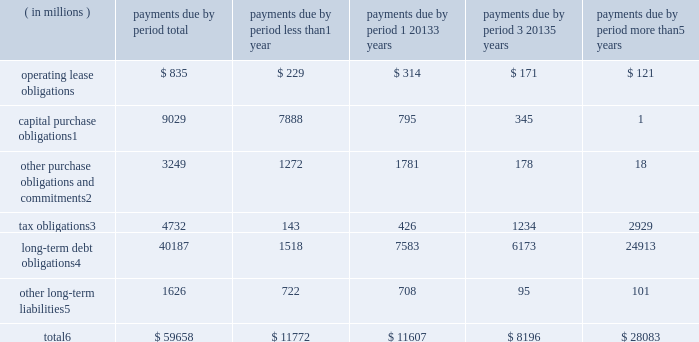Contractual obligations significant contractual obligations as of december 29 , 2018 were as follows: .
Capital purchase obligations1 9029 7888 795 345 1 other purchase obligations and commitments2 3249 1272 1781 178 18 tax obligations3 4732 143 426 1234 2929 long-term debt obligations4 40187 1518 7583 6173 24913 other long-term liabilities5 1626 722 708 95 101 total6 $ 59658 $ 11772 $ 11607 $ 8196 $ 28083 1 capital purchase obligations represent commitments for the construction or purchase of property , plant and equipment .
They were not recorded as liabilities on our consolidated balance sheets as of december 29 , 2018 , as we had not yet received the related goods nor taken title to the property .
2 other purchase obligations and commitments include payments due under various types of licenses and agreements to purchase goods or services , as well as payments due under non-contingent funding obligations .
3 tax obligations represent the future cash payments related to tax reform enacted in 2017 for the one-time transition tax on our previously untaxed foreign earnings .
For further information , see 201cnote 9 : income taxes 201d within the consolidated financial statements .
4 amounts represent principal payments for all debt obligations and interest payments for fixed-rate debt obligations .
Interest payments on floating-rate debt obligations , as well as the impact of fixed-rate to floating-rate debt swaps , are excluded .
Debt obligations are classified based on their stated maturity date , regardless of their classification on the consolidated balance sheets .
Any future settlement of convertible debt would impact our cash payments .
5 amounts represent future cash payments to satisfy other long-term liabilities recorded on our consolidated balance sheets , including the short-term portion of these long-term liabilities .
Derivative instruments are excluded from the preceding table , as they do not represent the amounts that may ultimately be paid .
6 total excludes contractual obligations already recorded on our consolidated balance sheets as current liabilities , except for the short-term portions of long-term debt obligations and other long-term liabilities .
The expected timing of payments of the obligations in the preceding table is estimated based on current information .
Timing of payments and actual amounts paid may be different , depending on the time of receipt of goods or services , or changes to agreed- upon amounts for some obligations .
Contractual obligations for purchases of goods or services included in 201cother purchase obligations and commitments 201d in the preceding table include agreements that are enforceable and legally binding and that specify all significant terms , including fixed or minimum quantities to be purchased ; fixed , minimum , or variable price provisions ; and the approximate timing of the transaction .
For obligations with cancellation provisions , the amounts included in the preceding table were limited to the non-cancelable portion of the agreement terms or the minimum cancellation fee .
For the purchase of raw materials , we have entered into certain agreements that specify minimum prices and quantities based on a percentage of the total available market or based on a percentage of our future purchasing requirements .
Due to the uncertainty of the future market and our future purchasing requirements , as well as the non-binding nature of these agreements , obligations under these agreements have been excluded from the preceding table .
Our purchase orders for other products are based on our current manufacturing needs and are fulfilled by our vendors within short time horizons .
In addition , some of our purchase orders represent authorizations to purchase rather than binding agreements .
Contractual obligations that are contingent upon the achievement of certain milestones have been excluded from the preceding table .
Most of our milestone-based contracts are tooling related for the purchase of capital equipment .
These arrangements are not considered contractual obligations until the milestone is met by the counterparty .
As of december 29 , 2018 , assuming that all future milestones are met , the additional required payments would be approximately $ 688 million .
For the majority of restricted stock units ( rsus ) granted , the number of shares of common stock issued on the date the rsus vest is net of the minimum statutory withholding requirements that we pay in cash to the appropriate taxing authorities on behalf of our employees .
The obligation to pay the relevant taxing authority is excluded from the preceding table , as the amount is contingent upon continued employment .
In addition , the amount of the obligation is unknown , as it is based in part on the market price of our common stock when the awards vest .
Md&a consolidated results and analysis 42 .
As of december 292018 what was the percent of the payments due in less than 1 year to the total? 
Rationale: as of december 292018 19.7% of the total was due due in less than 1 year to the
Computations: (11772 / 59658)
Answer: 0.19732. Contractual obligations significant contractual obligations as of december 29 , 2018 were as follows: .
Capital purchase obligations1 9029 7888 795 345 1 other purchase obligations and commitments2 3249 1272 1781 178 18 tax obligations3 4732 143 426 1234 2929 long-term debt obligations4 40187 1518 7583 6173 24913 other long-term liabilities5 1626 722 708 95 101 total6 $ 59658 $ 11772 $ 11607 $ 8196 $ 28083 1 capital purchase obligations represent commitments for the construction or purchase of property , plant and equipment .
They were not recorded as liabilities on our consolidated balance sheets as of december 29 , 2018 , as we had not yet received the related goods nor taken title to the property .
2 other purchase obligations and commitments include payments due under various types of licenses and agreements to purchase goods or services , as well as payments due under non-contingent funding obligations .
3 tax obligations represent the future cash payments related to tax reform enacted in 2017 for the one-time transition tax on our previously untaxed foreign earnings .
For further information , see 201cnote 9 : income taxes 201d within the consolidated financial statements .
4 amounts represent principal payments for all debt obligations and interest payments for fixed-rate debt obligations .
Interest payments on floating-rate debt obligations , as well as the impact of fixed-rate to floating-rate debt swaps , are excluded .
Debt obligations are classified based on their stated maturity date , regardless of their classification on the consolidated balance sheets .
Any future settlement of convertible debt would impact our cash payments .
5 amounts represent future cash payments to satisfy other long-term liabilities recorded on our consolidated balance sheets , including the short-term portion of these long-term liabilities .
Derivative instruments are excluded from the preceding table , as they do not represent the amounts that may ultimately be paid .
6 total excludes contractual obligations already recorded on our consolidated balance sheets as current liabilities , except for the short-term portions of long-term debt obligations and other long-term liabilities .
The expected timing of payments of the obligations in the preceding table is estimated based on current information .
Timing of payments and actual amounts paid may be different , depending on the time of receipt of goods or services , or changes to agreed- upon amounts for some obligations .
Contractual obligations for purchases of goods or services included in 201cother purchase obligations and commitments 201d in the preceding table include agreements that are enforceable and legally binding and that specify all significant terms , including fixed or minimum quantities to be purchased ; fixed , minimum , or variable price provisions ; and the approximate timing of the transaction .
For obligations with cancellation provisions , the amounts included in the preceding table were limited to the non-cancelable portion of the agreement terms or the minimum cancellation fee .
For the purchase of raw materials , we have entered into certain agreements that specify minimum prices and quantities based on a percentage of the total available market or based on a percentage of our future purchasing requirements .
Due to the uncertainty of the future market and our future purchasing requirements , as well as the non-binding nature of these agreements , obligations under these agreements have been excluded from the preceding table .
Our purchase orders for other products are based on our current manufacturing needs and are fulfilled by our vendors within short time horizons .
In addition , some of our purchase orders represent authorizations to purchase rather than binding agreements .
Contractual obligations that are contingent upon the achievement of certain milestones have been excluded from the preceding table .
Most of our milestone-based contracts are tooling related for the purchase of capital equipment .
These arrangements are not considered contractual obligations until the milestone is met by the counterparty .
As of december 29 , 2018 , assuming that all future milestones are met , the additional required payments would be approximately $ 688 million .
For the majority of restricted stock units ( rsus ) granted , the number of shares of common stock issued on the date the rsus vest is net of the minimum statutory withholding requirements that we pay in cash to the appropriate taxing authorities on behalf of our employees .
The obligation to pay the relevant taxing authority is excluded from the preceding table , as the amount is contingent upon continued employment .
In addition , the amount of the obligation is unknown , as it is based in part on the market price of our common stock when the awards vest .
Md&a consolidated results and analysis 42 .
As of december 292018 what was the percent of the operating lease obligations due 1 20133 years to the total operating lease obligations? 
Rationale: as of december 292018 37.6% of the total operating lease obligations was due in 1 20133 years
Computations: (314 / 835)
Answer: 0.37605. 